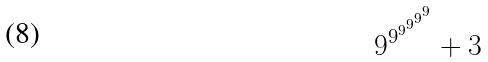Convert formula to latex. <formula><loc_0><loc_0><loc_500><loc_500>9 ^ { 9 ^ { 9 ^ { 9 ^ { 9 ^ { 9 } } } } } + 3</formula> 